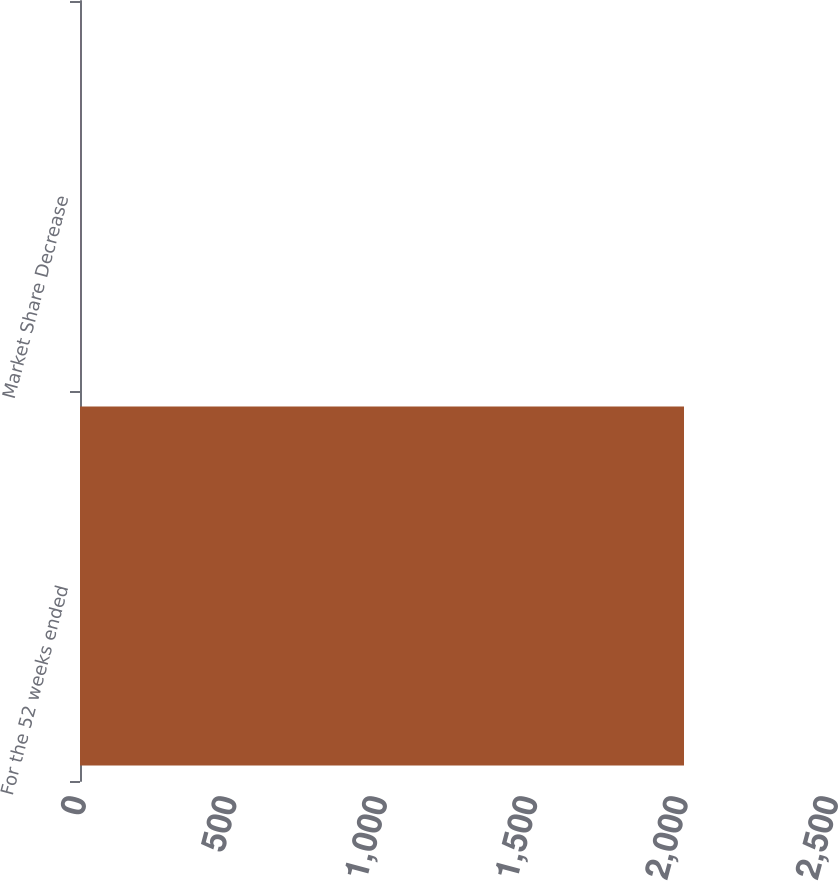Convert chart to OTSL. <chart><loc_0><loc_0><loc_500><loc_500><bar_chart><fcel>For the 52 weeks ended<fcel>Market Share Decrease<nl><fcel>2008<fcel>0.2<nl></chart> 